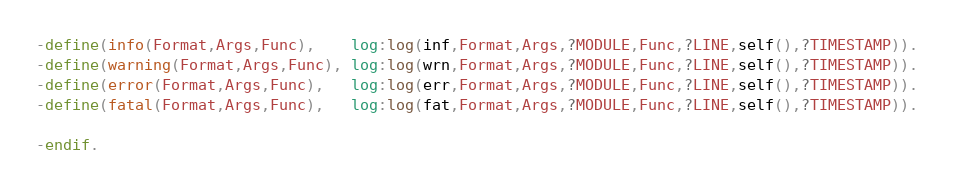<code> <loc_0><loc_0><loc_500><loc_500><_Erlang_>-define(info(Format,Args,Func),    log:log(inf,Format,Args,?MODULE,Func,?LINE,self(),?TIMESTAMP)).
-define(warning(Format,Args,Func), log:log(wrn,Format,Args,?MODULE,Func,?LINE,self(),?TIMESTAMP)).
-define(error(Format,Args,Func),   log:log(err,Format,Args,?MODULE,Func,?LINE,self(),?TIMESTAMP)).
-define(fatal(Format,Args,Func),   log:log(fat,Format,Args,?MODULE,Func,?LINE,self(),?TIMESTAMP)).

-endif.
</code> 